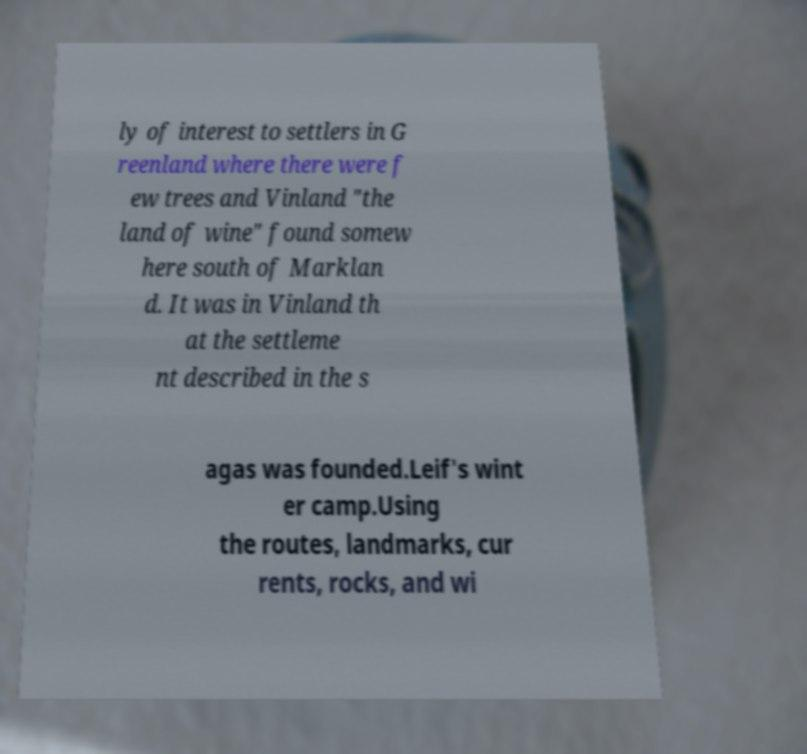For documentation purposes, I need the text within this image transcribed. Could you provide that? ly of interest to settlers in G reenland where there were f ew trees and Vinland "the land of wine" found somew here south of Marklan d. It was in Vinland th at the settleme nt described in the s agas was founded.Leif's wint er camp.Using the routes, landmarks, cur rents, rocks, and wi 